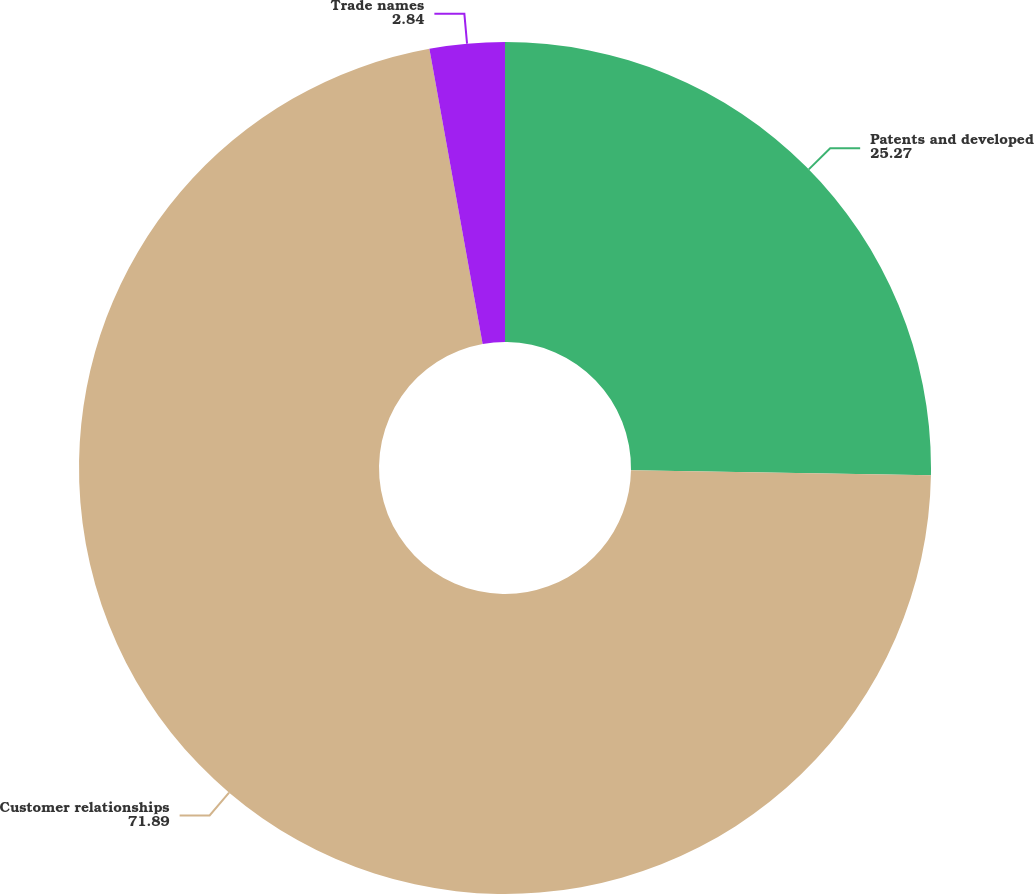<chart> <loc_0><loc_0><loc_500><loc_500><pie_chart><fcel>Patents and developed<fcel>Customer relationships<fcel>Trade names<nl><fcel>25.27%<fcel>71.89%<fcel>2.84%<nl></chart> 